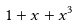Convert formula to latex. <formula><loc_0><loc_0><loc_500><loc_500>1 + x + x ^ { 3 }</formula> 